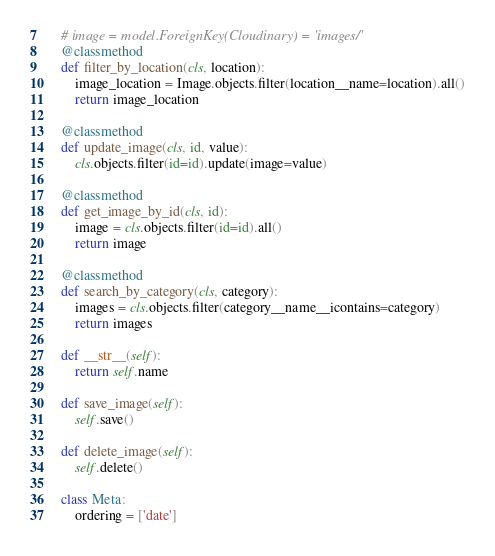<code> <loc_0><loc_0><loc_500><loc_500><_Python_>
    # image = model.ForeignKey(Cloudinary) = 'images/'
    @classmethod
    def filter_by_location(cls, location):
        image_location = Image.objects.filter(location__name=location).all()
        return image_location

    @classmethod
    def update_image(cls, id, value):
        cls.objects.filter(id=id).update(image=value)

    @classmethod
    def get_image_by_id(cls, id):
        image = cls.objects.filter(id=id).all()
        return image

    @classmethod
    def search_by_category(cls, category):
        images = cls.objects.filter(category__name__icontains=category)
        return images

    def __str__(self):
        return self.name

    def save_image(self):
        self.save()

    def delete_image(self):
        self.delete()

    class Meta:
        ordering = ['date']</code> 